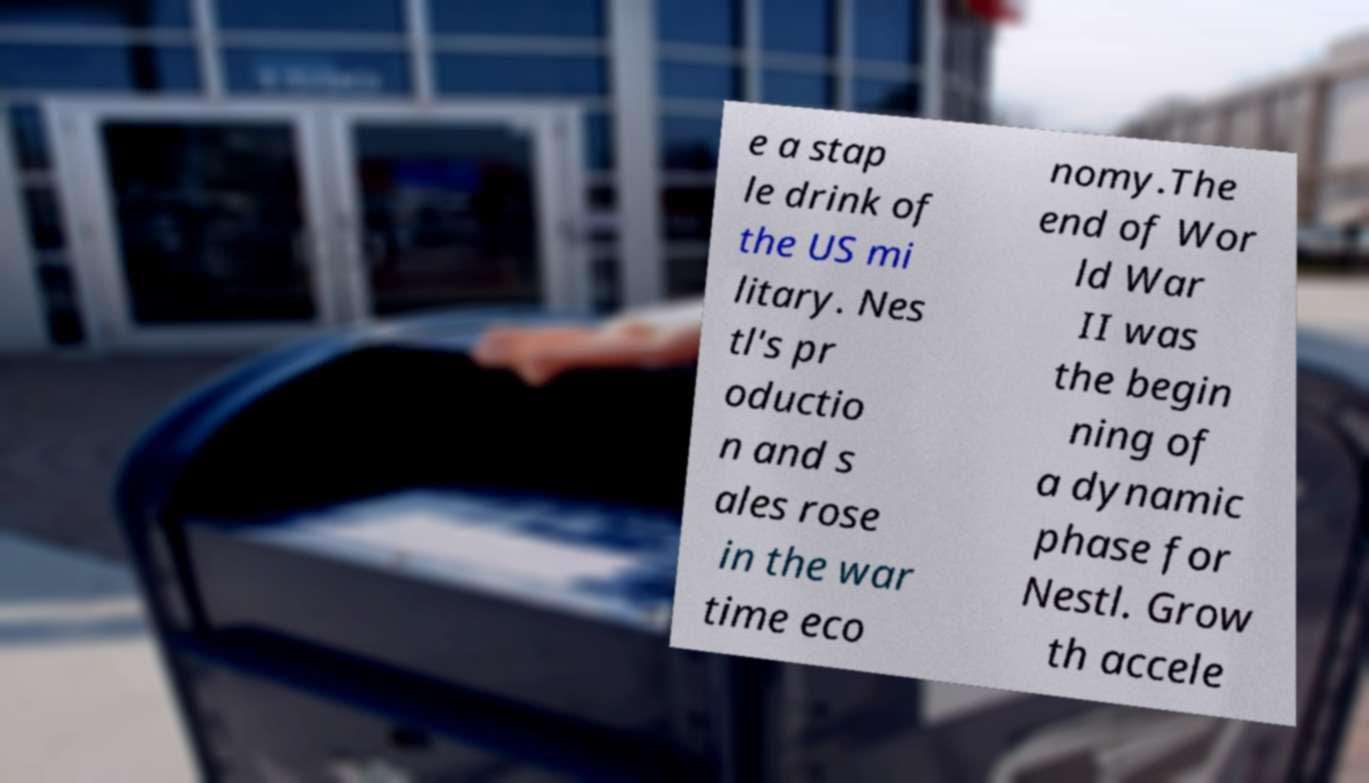Please identify and transcribe the text found in this image. e a stap le drink of the US mi litary. Nes tl's pr oductio n and s ales rose in the war time eco nomy.The end of Wor ld War II was the begin ning of a dynamic phase for Nestl. Grow th accele 